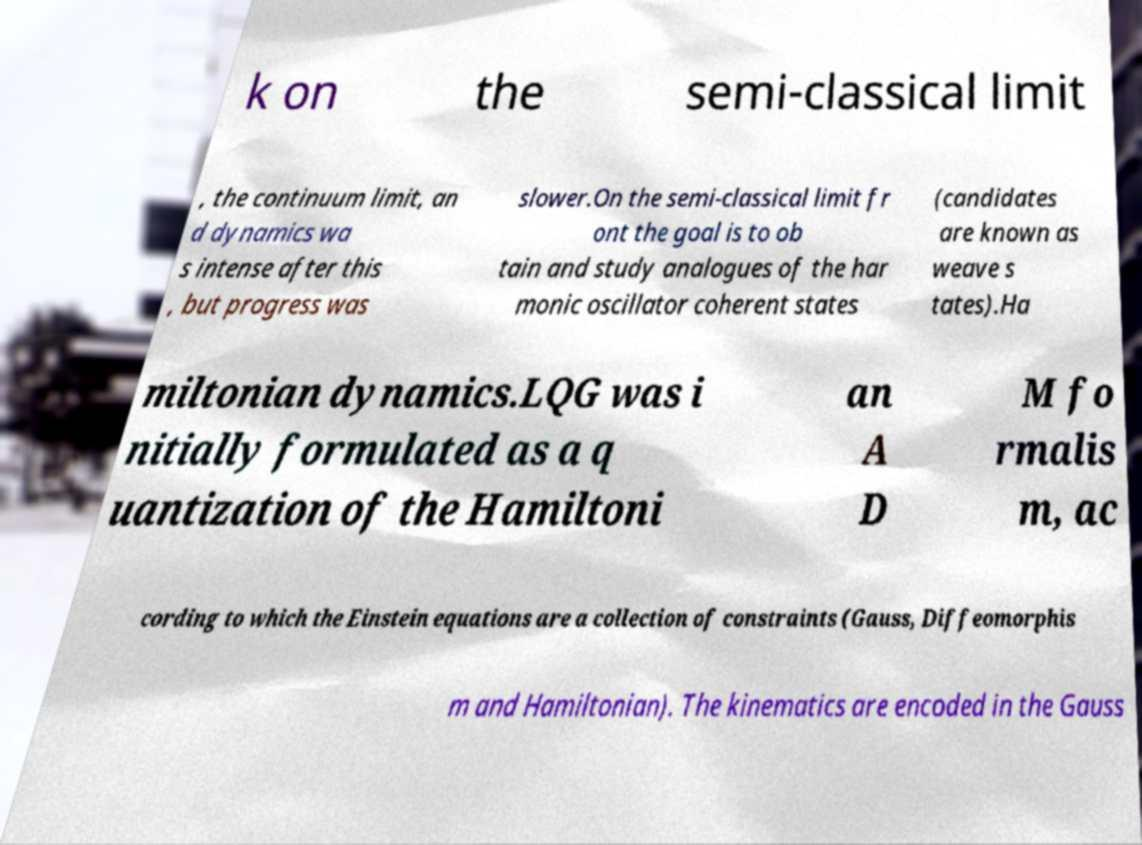Could you assist in decoding the text presented in this image and type it out clearly? k on the semi-classical limit , the continuum limit, an d dynamics wa s intense after this , but progress was slower.On the semi-classical limit fr ont the goal is to ob tain and study analogues of the har monic oscillator coherent states (candidates are known as weave s tates).Ha miltonian dynamics.LQG was i nitially formulated as a q uantization of the Hamiltoni an A D M fo rmalis m, ac cording to which the Einstein equations are a collection of constraints (Gauss, Diffeomorphis m and Hamiltonian). The kinematics are encoded in the Gauss 